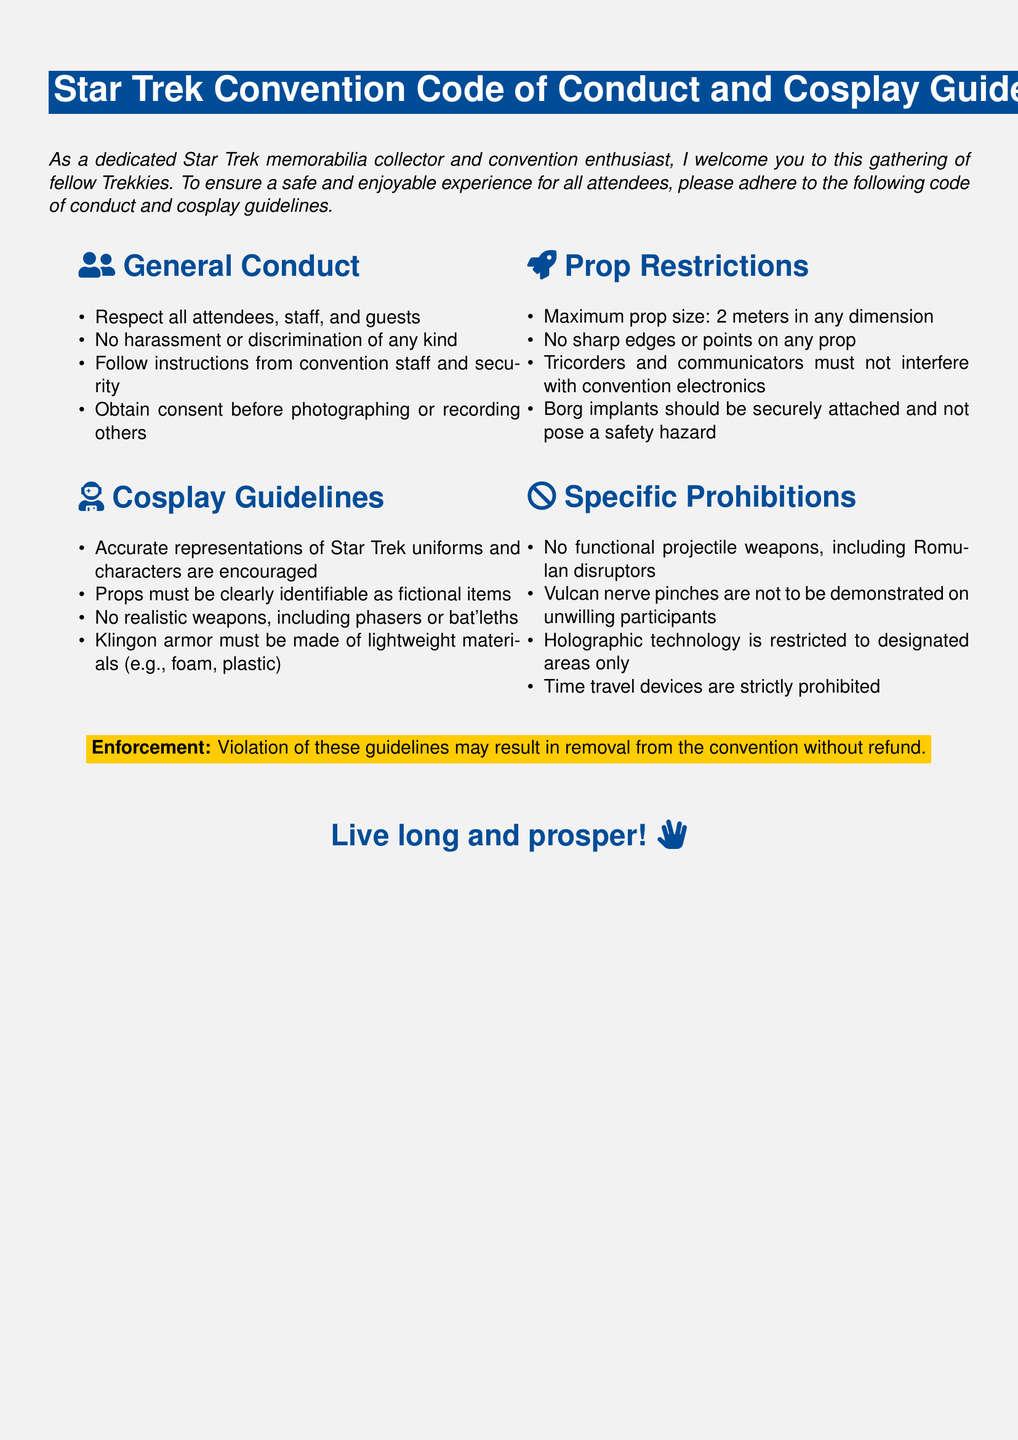What is the maximum prop size allowed? The document states that the maximum prop size is 2 meters in any dimension.
Answer: 2 meters What type of materials should Klingon armor be made of? The guidelines specify that Klingon armor must be made of lightweight materials such as foam or plastic.
Answer: Lightweight materials What should props be clearly identifiable as? The guidelines indicate that props must be clearly identifiable as fictional items.
Answer: Fictional items Are functional projectile weapons allowed? The document specifically prohibits functional projectile weapons, including Romulan disruptors.
Answer: No What action is not allowed towards unwilling participants? The guidelines state that Vulcan nerve pinches are not to be demonstrated on unwilling participants.
Answer: Vulcan nerve pinches What color is the title background? The title background is colored with a shade known as starfleet blue.
Answer: Starfleet blue What may violation of the guidelines result in? The enforcement section indicates that violations may result in removal from the convention without refund.
Answer: Removal without refund What items must not interfere with convention electronics? The guidelines specify that tricorders and communicators must not interfere with convention electronics.
Answer: Tricorders and communicators What is encouraged in terms of costume representation? The document encourages accurate representations of Star Trek uniforms and characters in cosplay.
Answer: Accurate representations 